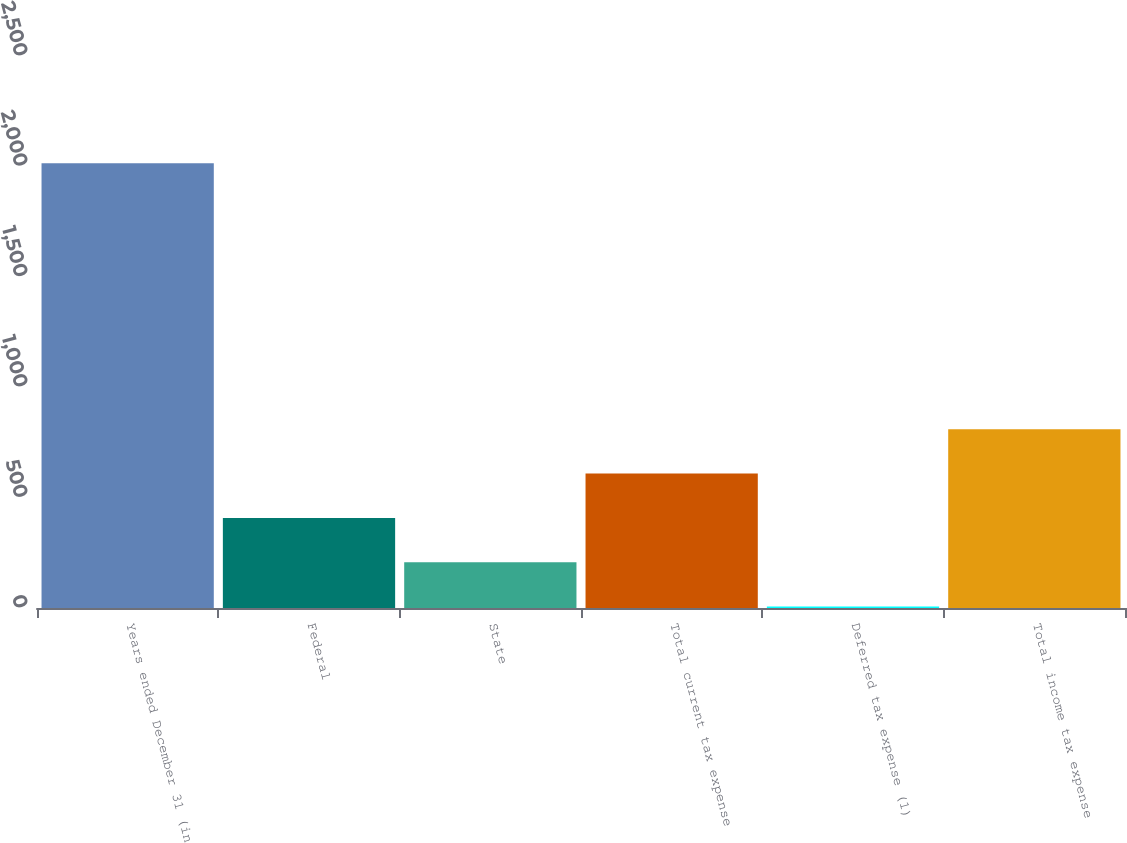Convert chart to OTSL. <chart><loc_0><loc_0><loc_500><loc_500><bar_chart><fcel>Years ended December 31 (in<fcel>Federal<fcel>State<fcel>Total current tax expense<fcel>Deferred tax expense (1)<fcel>Total income tax expense<nl><fcel>2014<fcel>408.16<fcel>207.43<fcel>608.89<fcel>6.7<fcel>809.62<nl></chart> 